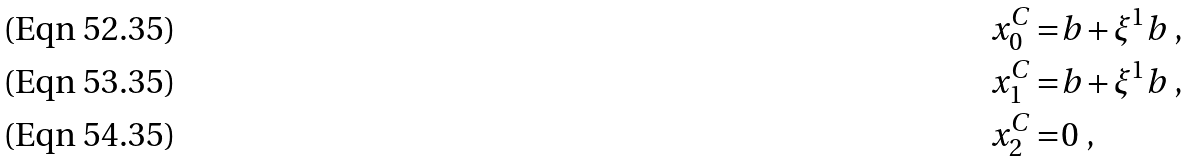<formula> <loc_0><loc_0><loc_500><loc_500>x _ { 0 } ^ { C } = & b + \xi ^ { 1 } b \ , \\ x _ { 1 } ^ { C } = & b + \xi ^ { 1 } b \ , \\ x _ { 2 } ^ { C } = & 0 \ ,</formula> 